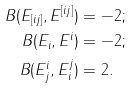<formula> <loc_0><loc_0><loc_500><loc_500>B ( E _ { [ i j ] } , E ^ { [ i j ] } ) & = - 2 ; \\ B ( E _ { i } , E ^ { i } ) & = - 2 ; \\ B ( E ^ { i } _ { j } , E ^ { j } _ { i } ) & = 2 .</formula> 